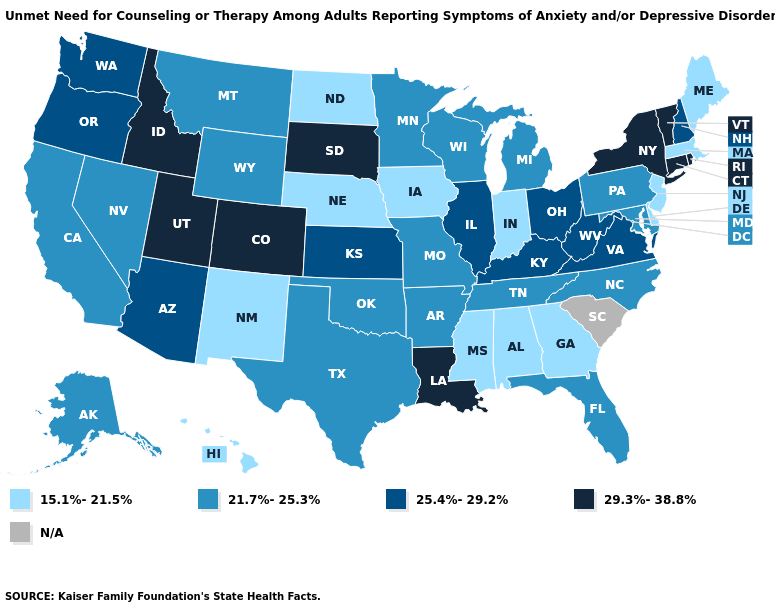Among the states that border South Dakota , which have the lowest value?
Be succinct. Iowa, Nebraska, North Dakota. Among the states that border Mississippi , which have the highest value?
Answer briefly. Louisiana. Does Colorado have the highest value in the USA?
Give a very brief answer. Yes. What is the value of Pennsylvania?
Be succinct. 21.7%-25.3%. What is the highest value in the Northeast ?
Keep it brief. 29.3%-38.8%. Does Maine have the highest value in the USA?
Be succinct. No. What is the value of New Mexico?
Answer briefly. 15.1%-21.5%. What is the lowest value in the MidWest?
Answer briefly. 15.1%-21.5%. What is the value of Nevada?
Answer briefly. 21.7%-25.3%. What is the value of Arizona?
Answer briefly. 25.4%-29.2%. How many symbols are there in the legend?
Write a very short answer. 5. How many symbols are there in the legend?
Short answer required. 5. Does Vermont have the lowest value in the Northeast?
Be succinct. No. Among the states that border North Dakota , which have the lowest value?
Give a very brief answer. Minnesota, Montana. Name the states that have a value in the range 21.7%-25.3%?
Quick response, please. Alaska, Arkansas, California, Florida, Maryland, Michigan, Minnesota, Missouri, Montana, Nevada, North Carolina, Oklahoma, Pennsylvania, Tennessee, Texas, Wisconsin, Wyoming. 